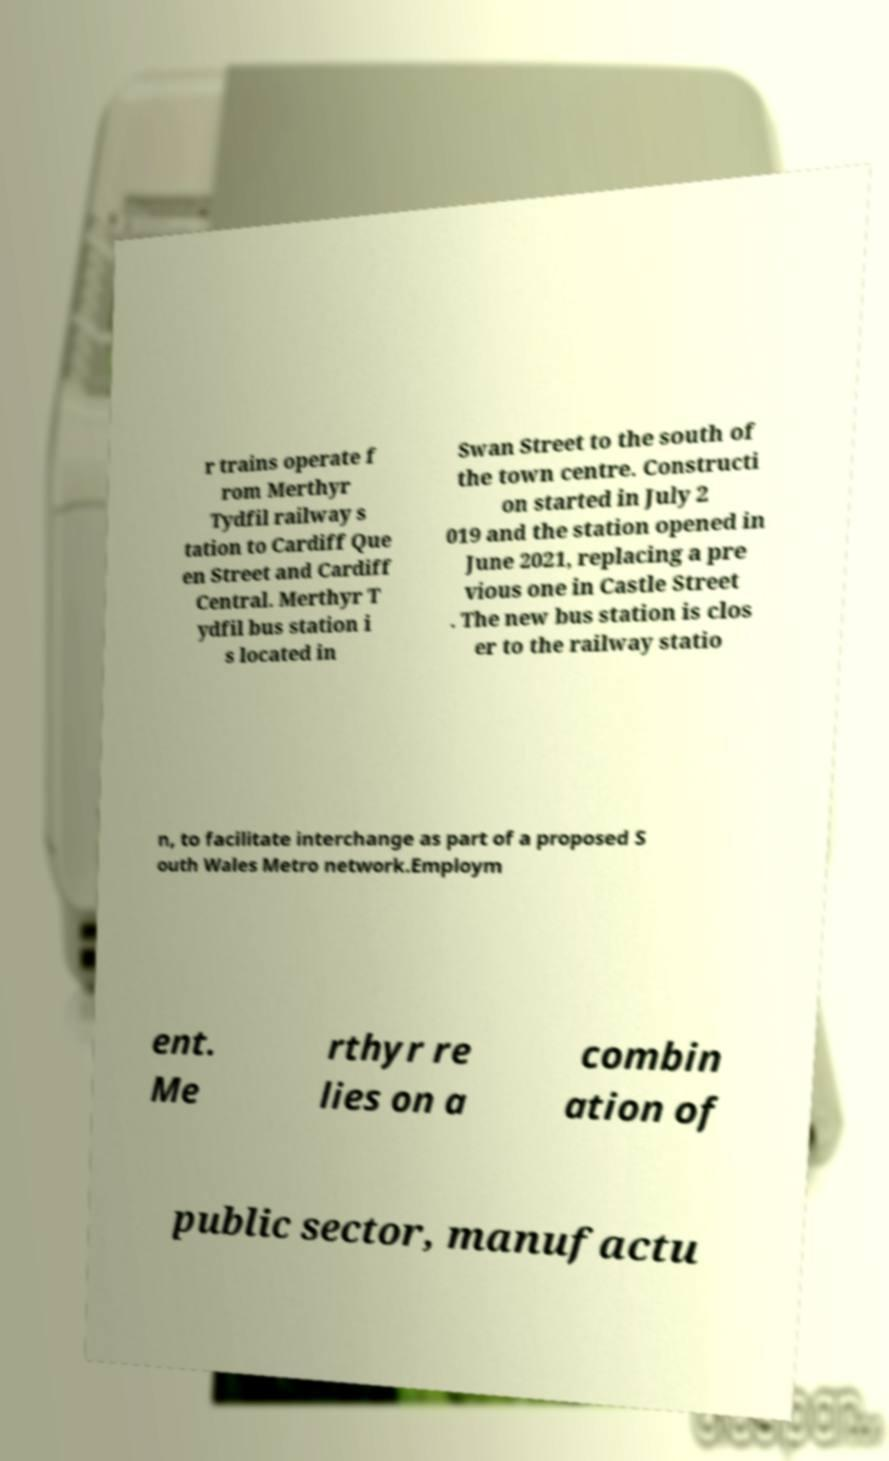Could you assist in decoding the text presented in this image and type it out clearly? r trains operate f rom Merthyr Tydfil railway s tation to Cardiff Que en Street and Cardiff Central. Merthyr T ydfil bus station i s located in Swan Street to the south of the town centre. Constructi on started in July 2 019 and the station opened in June 2021, replacing a pre vious one in Castle Street . The new bus station is clos er to the railway statio n, to facilitate interchange as part of a proposed S outh Wales Metro network.Employm ent. Me rthyr re lies on a combin ation of public sector, manufactu 